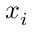Convert formula to latex. <formula><loc_0><loc_0><loc_500><loc_500>x _ { i }</formula> 